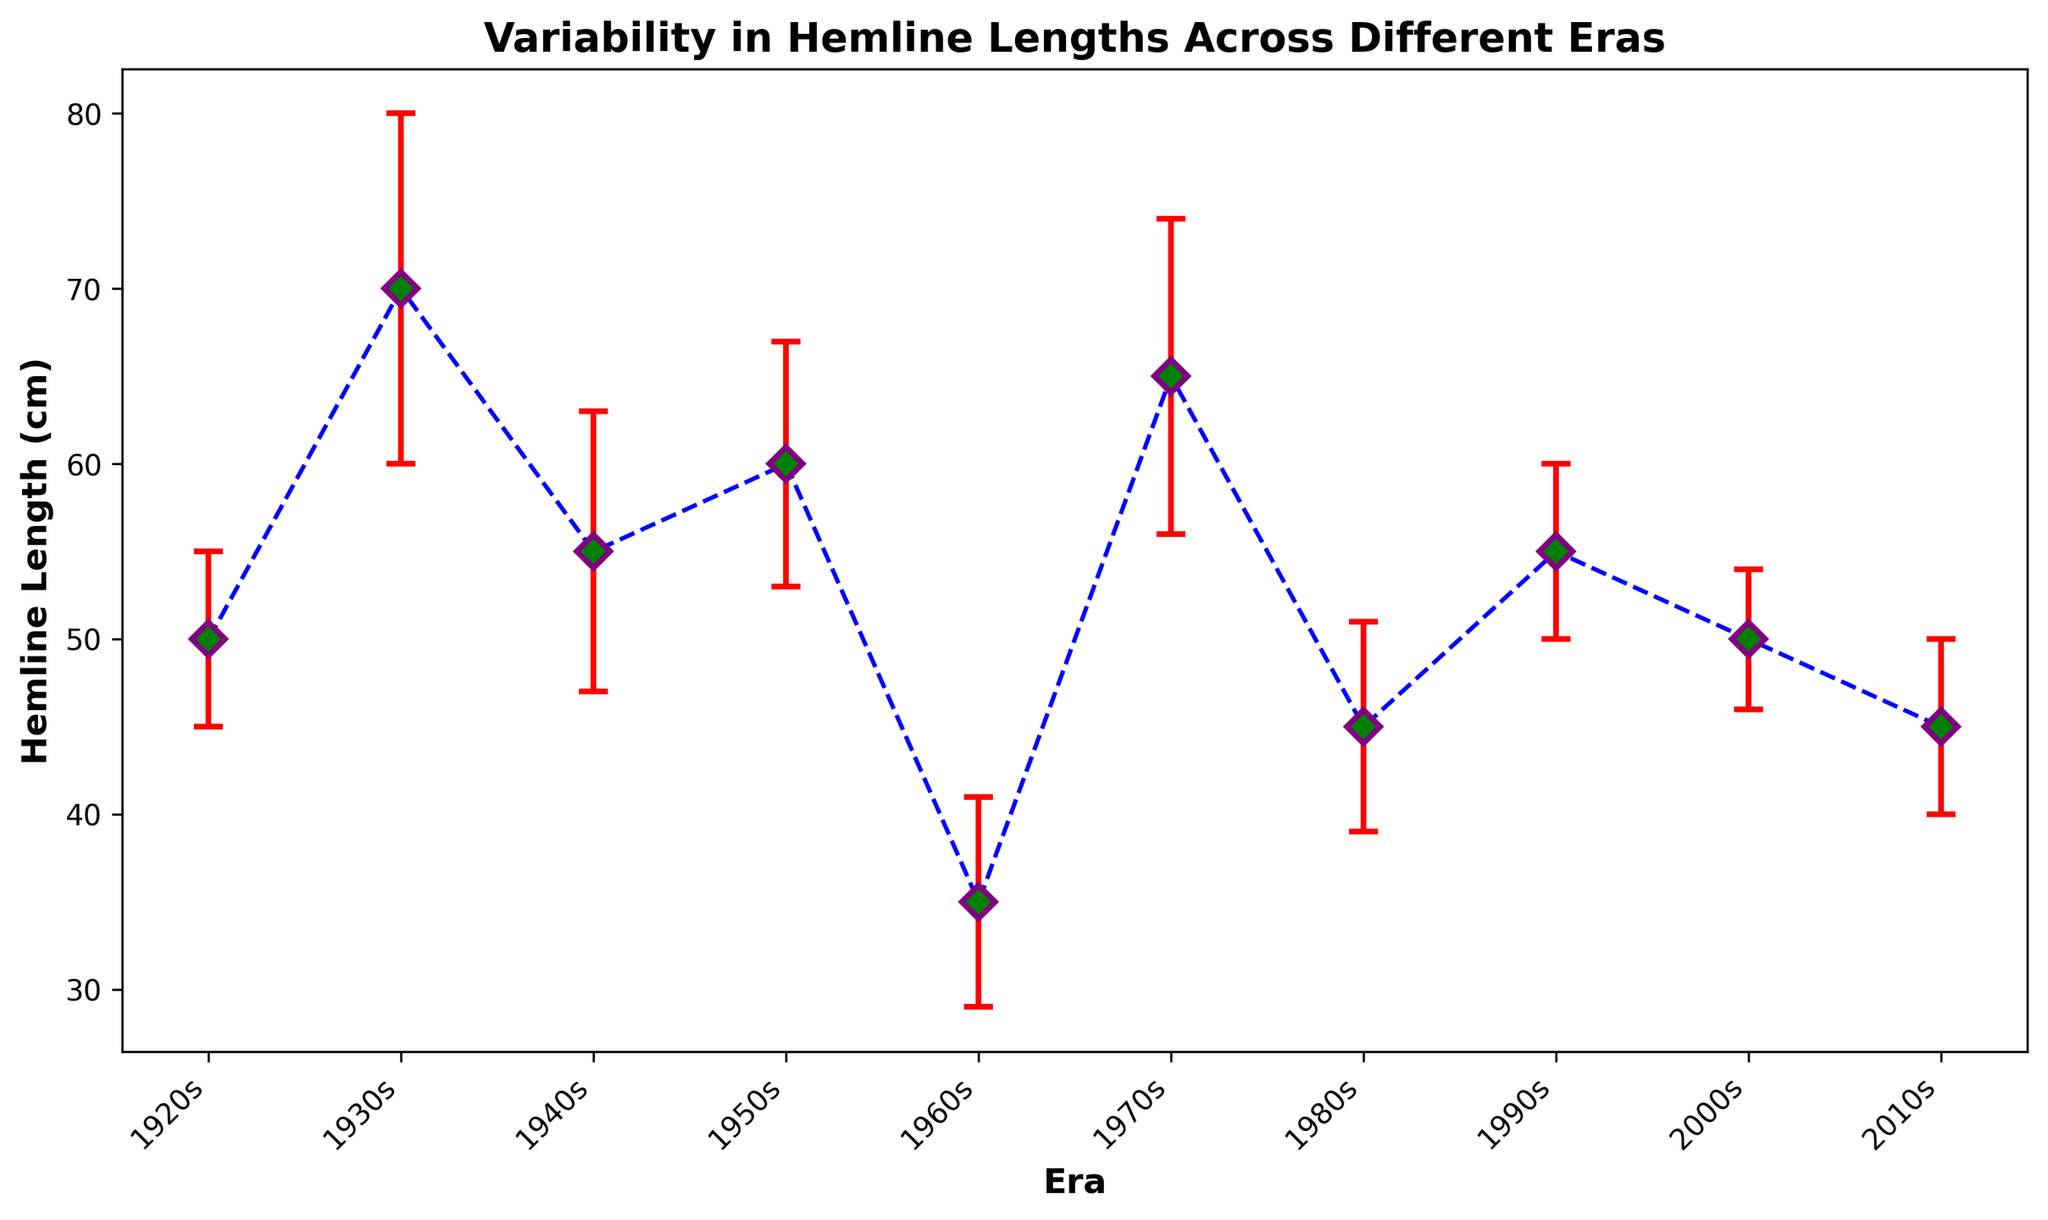What is the average hemline length across all eras? To calculate the average hemline length, sum all hemline lengths and divide by the number of eras. The eras' hemline lengths are: 50, 70, 55, 60, 35, 65, 45, 55, 50, 45. Summing these values gives 530. Dividing by the number of eras (10) gives 530 / 10 = 53
Answer: 53 Which era has the highest hemline length? By visually checking the hemline lengths, the 1930s has the highest value at 70 cm
Answer: 1930s In which era does the hemline length have the smallest variability? Variability is measured by the standard deviation. From the visual observation, the 2000s era has the smallest standard deviation of 4 cm
Answer: 2000s Which era has a lower hemline length: the 1960s or the 1980s? By visually checking the hemline lengths, the 1960s has a hemline length of 35 cm, whereas the 1980s has a hemline length of 45 cm. Therefore, the 1960s has a lower hemline length
Answer: 1960s 